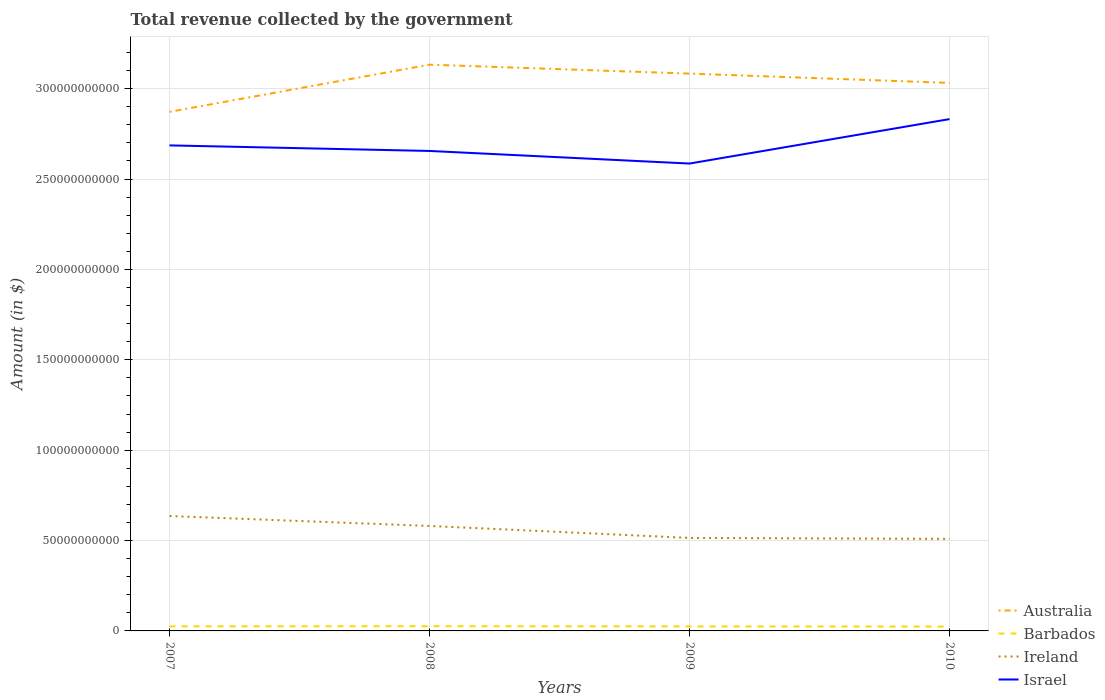Does the line corresponding to Ireland intersect with the line corresponding to Barbados?
Offer a terse response. No. Across all years, what is the maximum total revenue collected by the government in Ireland?
Make the answer very short. 5.09e+1. In which year was the total revenue collected by the government in Ireland maximum?
Provide a succinct answer. 2010. What is the total total revenue collected by the government in Ireland in the graph?
Provide a short and direct response. 5.51e+09. What is the difference between the highest and the second highest total revenue collected by the government in Australia?
Your response must be concise. 2.61e+1. How many years are there in the graph?
Provide a succinct answer. 4. How are the legend labels stacked?
Keep it short and to the point. Vertical. What is the title of the graph?
Offer a terse response. Total revenue collected by the government. Does "Syrian Arab Republic" appear as one of the legend labels in the graph?
Offer a terse response. No. What is the label or title of the X-axis?
Keep it short and to the point. Years. What is the label or title of the Y-axis?
Give a very brief answer. Amount (in $). What is the Amount (in $) in Australia in 2007?
Provide a succinct answer. 2.87e+11. What is the Amount (in $) in Barbados in 2007?
Keep it short and to the point. 2.53e+09. What is the Amount (in $) of Ireland in 2007?
Offer a terse response. 6.36e+1. What is the Amount (in $) in Israel in 2007?
Give a very brief answer. 2.69e+11. What is the Amount (in $) in Australia in 2008?
Provide a short and direct response. 3.13e+11. What is the Amount (in $) in Barbados in 2008?
Make the answer very short. 2.61e+09. What is the Amount (in $) of Ireland in 2008?
Ensure brevity in your answer.  5.81e+1. What is the Amount (in $) of Israel in 2008?
Your answer should be compact. 2.66e+11. What is the Amount (in $) of Australia in 2009?
Offer a very short reply. 3.08e+11. What is the Amount (in $) in Barbados in 2009?
Offer a terse response. 2.50e+09. What is the Amount (in $) of Ireland in 2009?
Provide a succinct answer. 5.15e+1. What is the Amount (in $) in Israel in 2009?
Offer a very short reply. 2.59e+11. What is the Amount (in $) of Australia in 2010?
Your answer should be compact. 3.03e+11. What is the Amount (in $) of Barbados in 2010?
Keep it short and to the point. 2.41e+09. What is the Amount (in $) in Ireland in 2010?
Your response must be concise. 5.09e+1. What is the Amount (in $) of Israel in 2010?
Your response must be concise. 2.83e+11. Across all years, what is the maximum Amount (in $) in Australia?
Offer a very short reply. 3.13e+11. Across all years, what is the maximum Amount (in $) in Barbados?
Your answer should be very brief. 2.61e+09. Across all years, what is the maximum Amount (in $) in Ireland?
Provide a short and direct response. 6.36e+1. Across all years, what is the maximum Amount (in $) in Israel?
Offer a very short reply. 2.83e+11. Across all years, what is the minimum Amount (in $) in Australia?
Provide a short and direct response. 2.87e+11. Across all years, what is the minimum Amount (in $) of Barbados?
Make the answer very short. 2.41e+09. Across all years, what is the minimum Amount (in $) in Ireland?
Provide a short and direct response. 5.09e+1. Across all years, what is the minimum Amount (in $) of Israel?
Your answer should be very brief. 2.59e+11. What is the total Amount (in $) in Australia in the graph?
Offer a very short reply. 1.21e+12. What is the total Amount (in $) in Barbados in the graph?
Provide a short and direct response. 1.00e+1. What is the total Amount (in $) of Ireland in the graph?
Make the answer very short. 2.24e+11. What is the total Amount (in $) of Israel in the graph?
Offer a very short reply. 1.08e+12. What is the difference between the Amount (in $) of Australia in 2007 and that in 2008?
Give a very brief answer. -2.61e+1. What is the difference between the Amount (in $) in Barbados in 2007 and that in 2008?
Provide a short and direct response. -8.56e+07. What is the difference between the Amount (in $) of Ireland in 2007 and that in 2008?
Provide a short and direct response. 5.51e+09. What is the difference between the Amount (in $) of Israel in 2007 and that in 2008?
Ensure brevity in your answer.  3.08e+09. What is the difference between the Amount (in $) in Australia in 2007 and that in 2009?
Offer a very short reply. -2.12e+1. What is the difference between the Amount (in $) in Barbados in 2007 and that in 2009?
Your answer should be compact. 3.33e+07. What is the difference between the Amount (in $) of Ireland in 2007 and that in 2009?
Make the answer very short. 1.21e+1. What is the difference between the Amount (in $) of Israel in 2007 and that in 2009?
Offer a terse response. 1.00e+1. What is the difference between the Amount (in $) of Australia in 2007 and that in 2010?
Ensure brevity in your answer.  -1.60e+1. What is the difference between the Amount (in $) of Barbados in 2007 and that in 2010?
Offer a terse response. 1.22e+08. What is the difference between the Amount (in $) of Ireland in 2007 and that in 2010?
Provide a short and direct response. 1.27e+1. What is the difference between the Amount (in $) of Israel in 2007 and that in 2010?
Provide a short and direct response. -1.45e+1. What is the difference between the Amount (in $) in Australia in 2008 and that in 2009?
Offer a very short reply. 4.94e+09. What is the difference between the Amount (in $) of Barbados in 2008 and that in 2009?
Provide a short and direct response. 1.19e+08. What is the difference between the Amount (in $) in Ireland in 2008 and that in 2009?
Offer a terse response. 6.61e+09. What is the difference between the Amount (in $) of Israel in 2008 and that in 2009?
Keep it short and to the point. 6.97e+09. What is the difference between the Amount (in $) of Australia in 2008 and that in 2010?
Ensure brevity in your answer.  1.01e+1. What is the difference between the Amount (in $) of Barbados in 2008 and that in 2010?
Provide a short and direct response. 2.07e+08. What is the difference between the Amount (in $) in Ireland in 2008 and that in 2010?
Ensure brevity in your answer.  7.15e+09. What is the difference between the Amount (in $) of Israel in 2008 and that in 2010?
Your answer should be compact. -1.76e+1. What is the difference between the Amount (in $) in Australia in 2009 and that in 2010?
Ensure brevity in your answer.  5.14e+09. What is the difference between the Amount (in $) of Barbados in 2009 and that in 2010?
Your answer should be very brief. 8.86e+07. What is the difference between the Amount (in $) in Ireland in 2009 and that in 2010?
Provide a short and direct response. 5.34e+08. What is the difference between the Amount (in $) of Israel in 2009 and that in 2010?
Your answer should be very brief. -2.46e+1. What is the difference between the Amount (in $) in Australia in 2007 and the Amount (in $) in Barbados in 2008?
Ensure brevity in your answer.  2.85e+11. What is the difference between the Amount (in $) in Australia in 2007 and the Amount (in $) in Ireland in 2008?
Offer a terse response. 2.29e+11. What is the difference between the Amount (in $) in Australia in 2007 and the Amount (in $) in Israel in 2008?
Offer a terse response. 2.16e+1. What is the difference between the Amount (in $) in Barbados in 2007 and the Amount (in $) in Ireland in 2008?
Your answer should be compact. -5.55e+1. What is the difference between the Amount (in $) in Barbados in 2007 and the Amount (in $) in Israel in 2008?
Provide a succinct answer. -2.63e+11. What is the difference between the Amount (in $) of Ireland in 2007 and the Amount (in $) of Israel in 2008?
Your response must be concise. -2.02e+11. What is the difference between the Amount (in $) of Australia in 2007 and the Amount (in $) of Barbados in 2009?
Provide a succinct answer. 2.85e+11. What is the difference between the Amount (in $) of Australia in 2007 and the Amount (in $) of Ireland in 2009?
Provide a succinct answer. 2.36e+11. What is the difference between the Amount (in $) of Australia in 2007 and the Amount (in $) of Israel in 2009?
Keep it short and to the point. 2.86e+1. What is the difference between the Amount (in $) in Barbados in 2007 and the Amount (in $) in Ireland in 2009?
Offer a terse response. -4.89e+1. What is the difference between the Amount (in $) in Barbados in 2007 and the Amount (in $) in Israel in 2009?
Your answer should be compact. -2.56e+11. What is the difference between the Amount (in $) of Ireland in 2007 and the Amount (in $) of Israel in 2009?
Offer a very short reply. -1.95e+11. What is the difference between the Amount (in $) in Australia in 2007 and the Amount (in $) in Barbados in 2010?
Provide a short and direct response. 2.85e+11. What is the difference between the Amount (in $) in Australia in 2007 and the Amount (in $) in Ireland in 2010?
Provide a succinct answer. 2.36e+11. What is the difference between the Amount (in $) in Australia in 2007 and the Amount (in $) in Israel in 2010?
Your response must be concise. 4.01e+09. What is the difference between the Amount (in $) of Barbados in 2007 and the Amount (in $) of Ireland in 2010?
Your answer should be very brief. -4.84e+1. What is the difference between the Amount (in $) of Barbados in 2007 and the Amount (in $) of Israel in 2010?
Make the answer very short. -2.81e+11. What is the difference between the Amount (in $) in Ireland in 2007 and the Amount (in $) in Israel in 2010?
Keep it short and to the point. -2.20e+11. What is the difference between the Amount (in $) in Australia in 2008 and the Amount (in $) in Barbados in 2009?
Provide a succinct answer. 3.11e+11. What is the difference between the Amount (in $) of Australia in 2008 and the Amount (in $) of Ireland in 2009?
Your answer should be very brief. 2.62e+11. What is the difference between the Amount (in $) of Australia in 2008 and the Amount (in $) of Israel in 2009?
Offer a terse response. 5.47e+1. What is the difference between the Amount (in $) in Barbados in 2008 and the Amount (in $) in Ireland in 2009?
Offer a very short reply. -4.88e+1. What is the difference between the Amount (in $) in Barbados in 2008 and the Amount (in $) in Israel in 2009?
Your answer should be compact. -2.56e+11. What is the difference between the Amount (in $) in Ireland in 2008 and the Amount (in $) in Israel in 2009?
Offer a very short reply. -2.01e+11. What is the difference between the Amount (in $) of Australia in 2008 and the Amount (in $) of Barbados in 2010?
Offer a terse response. 3.11e+11. What is the difference between the Amount (in $) in Australia in 2008 and the Amount (in $) in Ireland in 2010?
Your response must be concise. 2.62e+11. What is the difference between the Amount (in $) of Australia in 2008 and the Amount (in $) of Israel in 2010?
Your response must be concise. 3.01e+1. What is the difference between the Amount (in $) of Barbados in 2008 and the Amount (in $) of Ireland in 2010?
Ensure brevity in your answer.  -4.83e+1. What is the difference between the Amount (in $) of Barbados in 2008 and the Amount (in $) of Israel in 2010?
Give a very brief answer. -2.81e+11. What is the difference between the Amount (in $) in Ireland in 2008 and the Amount (in $) in Israel in 2010?
Offer a terse response. -2.25e+11. What is the difference between the Amount (in $) of Australia in 2009 and the Amount (in $) of Barbados in 2010?
Your answer should be very brief. 3.06e+11. What is the difference between the Amount (in $) of Australia in 2009 and the Amount (in $) of Ireland in 2010?
Ensure brevity in your answer.  2.57e+11. What is the difference between the Amount (in $) in Australia in 2009 and the Amount (in $) in Israel in 2010?
Keep it short and to the point. 2.52e+1. What is the difference between the Amount (in $) of Barbados in 2009 and the Amount (in $) of Ireland in 2010?
Your answer should be very brief. -4.84e+1. What is the difference between the Amount (in $) of Barbados in 2009 and the Amount (in $) of Israel in 2010?
Offer a terse response. -2.81e+11. What is the difference between the Amount (in $) of Ireland in 2009 and the Amount (in $) of Israel in 2010?
Your response must be concise. -2.32e+11. What is the average Amount (in $) in Australia per year?
Make the answer very short. 3.03e+11. What is the average Amount (in $) of Barbados per year?
Your response must be concise. 2.51e+09. What is the average Amount (in $) of Ireland per year?
Offer a very short reply. 5.60e+1. What is the average Amount (in $) in Israel per year?
Provide a short and direct response. 2.69e+11. In the year 2007, what is the difference between the Amount (in $) in Australia and Amount (in $) in Barbados?
Your answer should be compact. 2.85e+11. In the year 2007, what is the difference between the Amount (in $) of Australia and Amount (in $) of Ireland?
Your answer should be very brief. 2.24e+11. In the year 2007, what is the difference between the Amount (in $) in Australia and Amount (in $) in Israel?
Offer a terse response. 1.86e+1. In the year 2007, what is the difference between the Amount (in $) in Barbados and Amount (in $) in Ireland?
Keep it short and to the point. -6.10e+1. In the year 2007, what is the difference between the Amount (in $) in Barbados and Amount (in $) in Israel?
Ensure brevity in your answer.  -2.66e+11. In the year 2007, what is the difference between the Amount (in $) in Ireland and Amount (in $) in Israel?
Offer a terse response. -2.05e+11. In the year 2008, what is the difference between the Amount (in $) in Australia and Amount (in $) in Barbados?
Ensure brevity in your answer.  3.11e+11. In the year 2008, what is the difference between the Amount (in $) of Australia and Amount (in $) of Ireland?
Give a very brief answer. 2.55e+11. In the year 2008, what is the difference between the Amount (in $) of Australia and Amount (in $) of Israel?
Keep it short and to the point. 4.77e+1. In the year 2008, what is the difference between the Amount (in $) in Barbados and Amount (in $) in Ireland?
Offer a terse response. -5.55e+1. In the year 2008, what is the difference between the Amount (in $) of Barbados and Amount (in $) of Israel?
Offer a very short reply. -2.63e+11. In the year 2008, what is the difference between the Amount (in $) in Ireland and Amount (in $) in Israel?
Provide a short and direct response. -2.07e+11. In the year 2009, what is the difference between the Amount (in $) in Australia and Amount (in $) in Barbados?
Keep it short and to the point. 3.06e+11. In the year 2009, what is the difference between the Amount (in $) in Australia and Amount (in $) in Ireland?
Provide a succinct answer. 2.57e+11. In the year 2009, what is the difference between the Amount (in $) in Australia and Amount (in $) in Israel?
Ensure brevity in your answer.  4.98e+1. In the year 2009, what is the difference between the Amount (in $) in Barbados and Amount (in $) in Ireland?
Offer a terse response. -4.90e+1. In the year 2009, what is the difference between the Amount (in $) of Barbados and Amount (in $) of Israel?
Offer a very short reply. -2.56e+11. In the year 2009, what is the difference between the Amount (in $) of Ireland and Amount (in $) of Israel?
Keep it short and to the point. -2.07e+11. In the year 2010, what is the difference between the Amount (in $) of Australia and Amount (in $) of Barbados?
Provide a succinct answer. 3.01e+11. In the year 2010, what is the difference between the Amount (in $) in Australia and Amount (in $) in Ireland?
Provide a succinct answer. 2.52e+11. In the year 2010, what is the difference between the Amount (in $) of Australia and Amount (in $) of Israel?
Your answer should be very brief. 2.00e+1. In the year 2010, what is the difference between the Amount (in $) in Barbados and Amount (in $) in Ireland?
Give a very brief answer. -4.85e+1. In the year 2010, what is the difference between the Amount (in $) in Barbados and Amount (in $) in Israel?
Ensure brevity in your answer.  -2.81e+11. In the year 2010, what is the difference between the Amount (in $) of Ireland and Amount (in $) of Israel?
Offer a very short reply. -2.32e+11. What is the ratio of the Amount (in $) in Barbados in 2007 to that in 2008?
Ensure brevity in your answer.  0.97. What is the ratio of the Amount (in $) of Ireland in 2007 to that in 2008?
Your answer should be compact. 1.09. What is the ratio of the Amount (in $) in Israel in 2007 to that in 2008?
Your answer should be very brief. 1.01. What is the ratio of the Amount (in $) of Australia in 2007 to that in 2009?
Your answer should be compact. 0.93. What is the ratio of the Amount (in $) in Barbados in 2007 to that in 2009?
Make the answer very short. 1.01. What is the ratio of the Amount (in $) in Ireland in 2007 to that in 2009?
Your answer should be compact. 1.24. What is the ratio of the Amount (in $) of Israel in 2007 to that in 2009?
Your answer should be compact. 1.04. What is the ratio of the Amount (in $) of Australia in 2007 to that in 2010?
Offer a very short reply. 0.95. What is the ratio of the Amount (in $) in Barbados in 2007 to that in 2010?
Offer a terse response. 1.05. What is the ratio of the Amount (in $) in Ireland in 2007 to that in 2010?
Offer a terse response. 1.25. What is the ratio of the Amount (in $) in Israel in 2007 to that in 2010?
Your answer should be very brief. 0.95. What is the ratio of the Amount (in $) of Australia in 2008 to that in 2009?
Provide a succinct answer. 1.02. What is the ratio of the Amount (in $) in Barbados in 2008 to that in 2009?
Make the answer very short. 1.05. What is the ratio of the Amount (in $) in Ireland in 2008 to that in 2009?
Provide a succinct answer. 1.13. What is the ratio of the Amount (in $) in Israel in 2008 to that in 2009?
Give a very brief answer. 1.03. What is the ratio of the Amount (in $) of Australia in 2008 to that in 2010?
Give a very brief answer. 1.03. What is the ratio of the Amount (in $) of Barbados in 2008 to that in 2010?
Offer a very short reply. 1.09. What is the ratio of the Amount (in $) in Ireland in 2008 to that in 2010?
Provide a short and direct response. 1.14. What is the ratio of the Amount (in $) in Israel in 2008 to that in 2010?
Give a very brief answer. 0.94. What is the ratio of the Amount (in $) of Australia in 2009 to that in 2010?
Offer a very short reply. 1.02. What is the ratio of the Amount (in $) of Barbados in 2009 to that in 2010?
Provide a short and direct response. 1.04. What is the ratio of the Amount (in $) in Ireland in 2009 to that in 2010?
Ensure brevity in your answer.  1.01. What is the ratio of the Amount (in $) of Israel in 2009 to that in 2010?
Keep it short and to the point. 0.91. What is the difference between the highest and the second highest Amount (in $) in Australia?
Make the answer very short. 4.94e+09. What is the difference between the highest and the second highest Amount (in $) of Barbados?
Keep it short and to the point. 8.56e+07. What is the difference between the highest and the second highest Amount (in $) in Ireland?
Make the answer very short. 5.51e+09. What is the difference between the highest and the second highest Amount (in $) in Israel?
Ensure brevity in your answer.  1.45e+1. What is the difference between the highest and the lowest Amount (in $) in Australia?
Offer a terse response. 2.61e+1. What is the difference between the highest and the lowest Amount (in $) in Barbados?
Provide a short and direct response. 2.07e+08. What is the difference between the highest and the lowest Amount (in $) of Ireland?
Your answer should be compact. 1.27e+1. What is the difference between the highest and the lowest Amount (in $) in Israel?
Offer a terse response. 2.46e+1. 